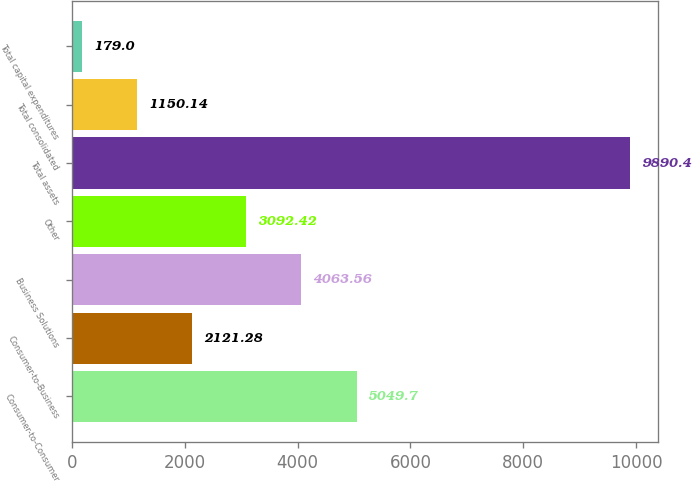Convert chart to OTSL. <chart><loc_0><loc_0><loc_500><loc_500><bar_chart><fcel>Consumer-to-Consumer<fcel>Consumer-to-Business<fcel>Business Solutions<fcel>Other<fcel>Total assets<fcel>Total consolidated<fcel>Total capital expenditures<nl><fcel>5049.7<fcel>2121.28<fcel>4063.56<fcel>3092.42<fcel>9890.4<fcel>1150.14<fcel>179<nl></chart> 